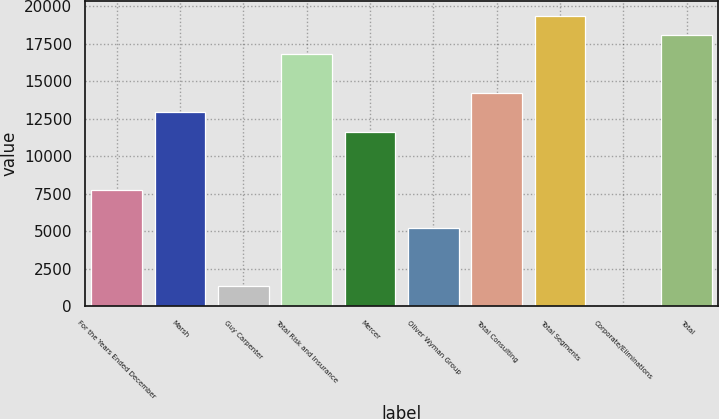<chart> <loc_0><loc_0><loc_500><loc_500><bar_chart><fcel>For the Years Ended December<fcel>Marsh<fcel>Guy Carpenter<fcel>Total Risk and Insurance<fcel>Mercer<fcel>Oliver Wyman Group<fcel>Total Consulting<fcel>Total Segments<fcel>Corporate/Eliminations<fcel>Total<nl><fcel>7775.8<fcel>12933<fcel>1329.3<fcel>16800.9<fcel>11643.7<fcel>5197.2<fcel>14222.3<fcel>19379.5<fcel>40<fcel>18090.2<nl></chart> 